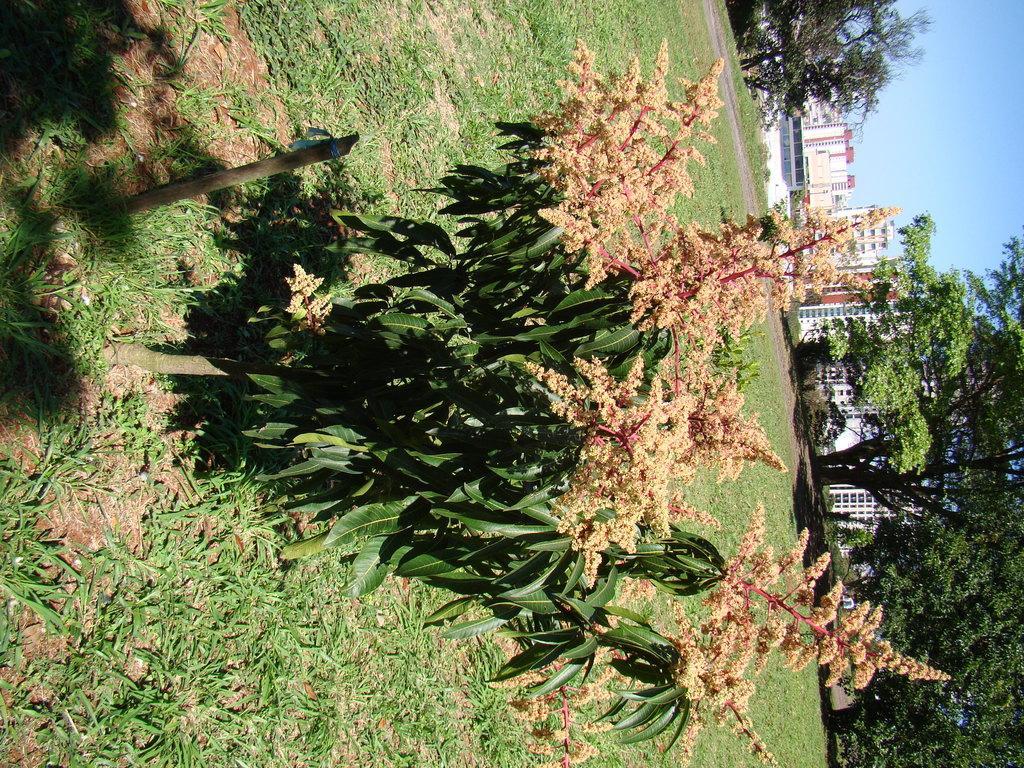Describe this image in one or two sentences. In the picture I can see plants, the grass and trees. In the background I can see buildings and the sky. 